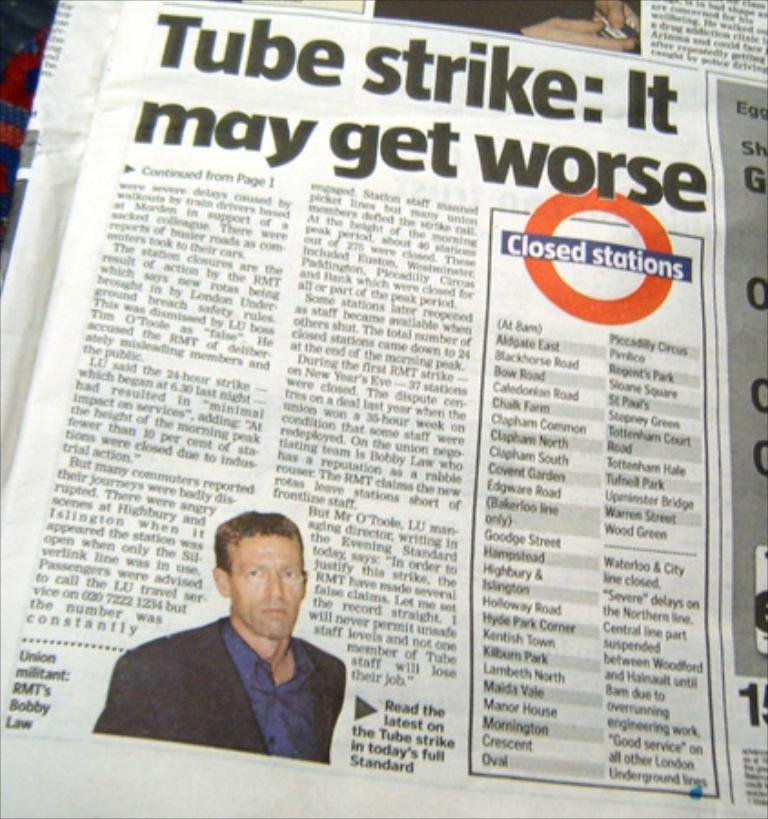<image>
Present a compact description of the photo's key features. An article about the tube strike includes which stations are closed. 